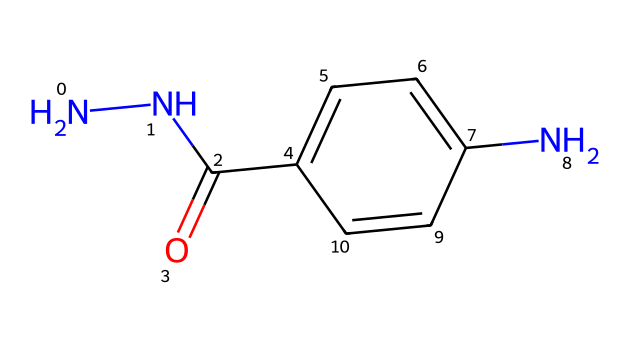What is the name of this chemical? The SMILES representation indicates a compound with nitrogen and carbon atoms, specifically containing two nitrogen atoms in a hydrazine functional group, and it resembles the structure of phenyl hydrazine derivatives. The exact name can be determined through the structure depicted, leading us to identify it as 4-aminobenzoylhydrazine.
Answer: 4-aminobenzoylhydrazine How many nitrogen atoms are present in this compound? By analyzing the SMILES representation, there are two distinct nitrogen atoms indicated in the structure, which are part of the hydrazine group (N-N).
Answer: two How many carbon atoms are in the structure? In the SMILES representation, there is a total count of six carbon atoms depicted in the aromatic ring and one carbon in the carbonyl group, summing up to seven carbons overall.
Answer: seven What functional group is represented by "C(=O)"? The "C(=O)" part represents a carbonyl functional group, indicating that there is a carbon atom doubly bonded to an oxygen atom, typically defining the compounds as amides or ketones depending on its placement.
Answer: carbonyl Is this compound likely to be soluble in water? Given that the compound contains polar functional groups like the amino (NH2) and carbonyl (C=O), it is expected to be soluble in water due to the ability of these groups to form hydrogen bonds with water molecules, promoting solubility.
Answer: yes What type of chemical is represented by this SMILES? This structure contains hydrazine and aromatic characteristics, placing it in the category of hydrazines specifically related to amines and aromatic compounds, often found in dyes and colorants for hair.
Answer: hydrazine 